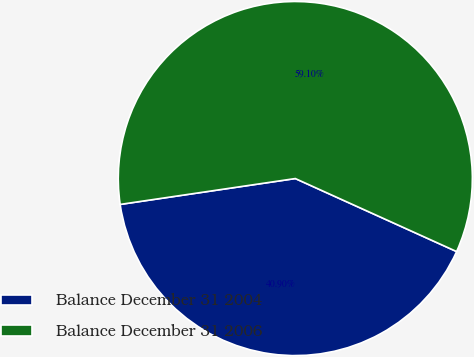Convert chart to OTSL. <chart><loc_0><loc_0><loc_500><loc_500><pie_chart><fcel>Balance December 31 2004<fcel>Balance December 31 2006<nl><fcel>40.9%<fcel>59.1%<nl></chart> 